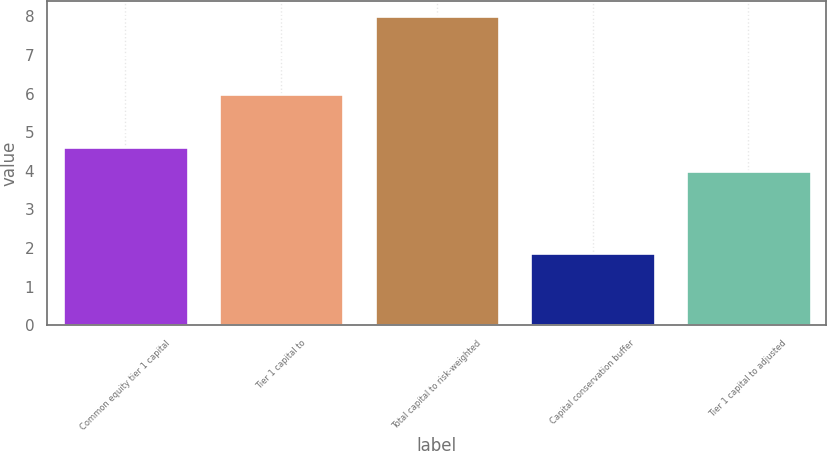<chart> <loc_0><loc_0><loc_500><loc_500><bar_chart><fcel>Common equity tier 1 capital<fcel>Tier 1 capital to<fcel>Total capital to risk-weighted<fcel>Capital conservation buffer<fcel>Tier 1 capital to adjusted<nl><fcel>4.61<fcel>6<fcel>8<fcel>1.88<fcel>4<nl></chart> 